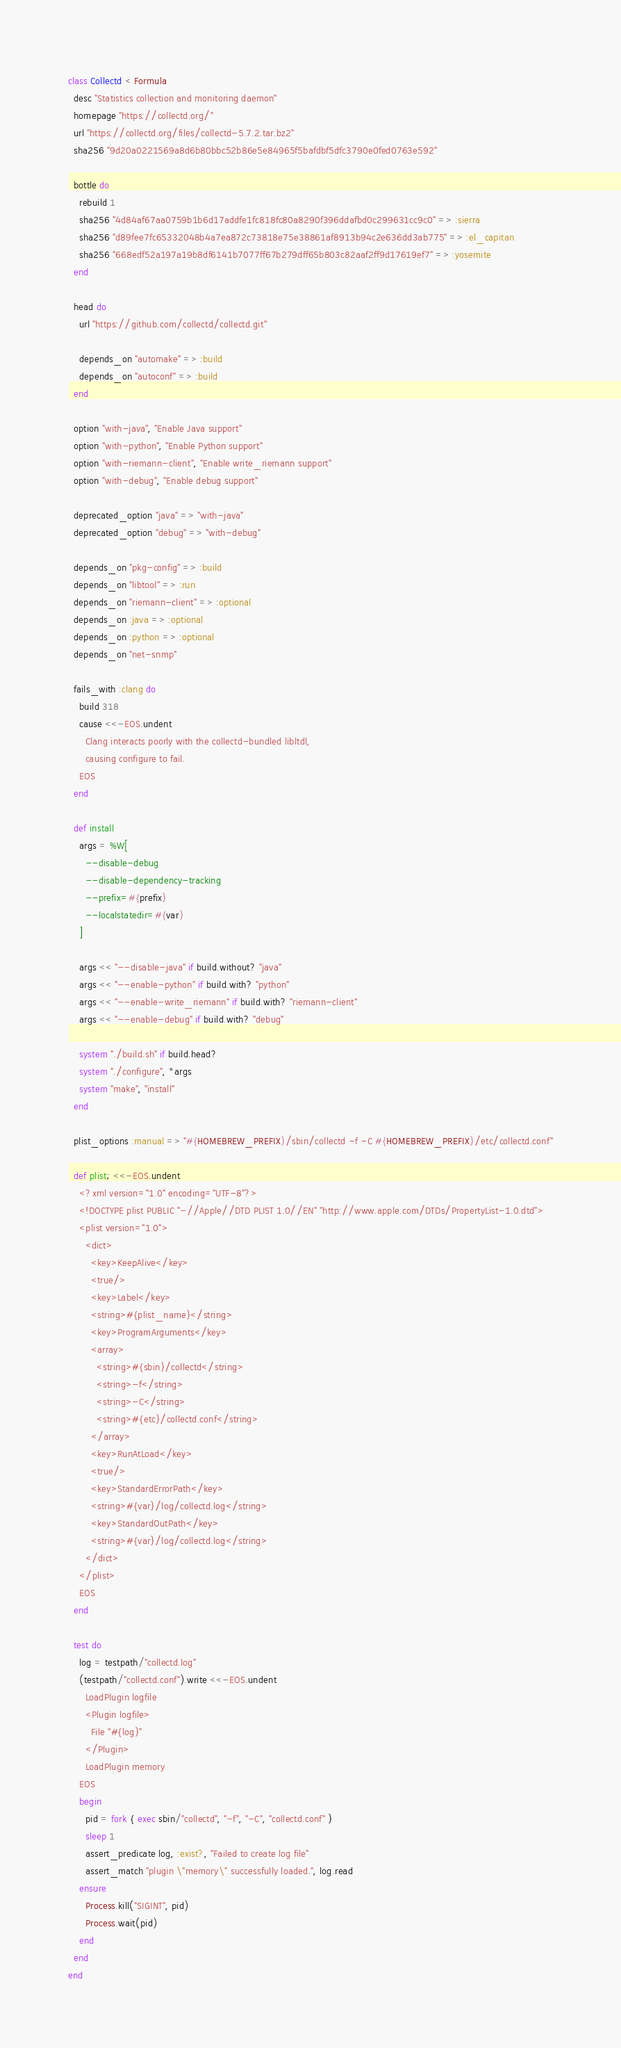<code> <loc_0><loc_0><loc_500><loc_500><_Ruby_>class Collectd < Formula
  desc "Statistics collection and monitoring daemon"
  homepage "https://collectd.org/"
  url "https://collectd.org/files/collectd-5.7.2.tar.bz2"
  sha256 "9d20a0221569a8d6b80bbc52b86e5e84965f5bafdbf5dfc3790e0fed0763e592"

  bottle do
    rebuild 1
    sha256 "4d84af67aa0759b1b6d17addfe1fc818fc80a8290f396ddafbd0c299631cc9c0" => :sierra
    sha256 "d89fee7fc65332048b4a7ea872c73818e75e38861af8913b94c2e636dd3ab775" => :el_capitan
    sha256 "668edf52a197a19b8df6141b7077ff67b279dff65b803c82aaf2ff9d17619ef7" => :yosemite
  end

  head do
    url "https://github.com/collectd/collectd.git"

    depends_on "automake" => :build
    depends_on "autoconf" => :build
  end

  option "with-java", "Enable Java support"
  option "with-python", "Enable Python support"
  option "with-riemann-client", "Enable write_riemann support"
  option "with-debug", "Enable debug support"

  deprecated_option "java" => "with-java"
  deprecated_option "debug" => "with-debug"

  depends_on "pkg-config" => :build
  depends_on "libtool" => :run
  depends_on "riemann-client" => :optional
  depends_on :java => :optional
  depends_on :python => :optional
  depends_on "net-snmp"

  fails_with :clang do
    build 318
    cause <<-EOS.undent
      Clang interacts poorly with the collectd-bundled libltdl,
      causing configure to fail.
    EOS
  end

  def install
    args = %W[
      --disable-debug
      --disable-dependency-tracking
      --prefix=#{prefix}
      --localstatedir=#{var}
    ]

    args << "--disable-java" if build.without? "java"
    args << "--enable-python" if build.with? "python"
    args << "--enable-write_riemann" if build.with? "riemann-client"
    args << "--enable-debug" if build.with? "debug"

    system "./build.sh" if build.head?
    system "./configure", *args
    system "make", "install"
  end

  plist_options :manual => "#{HOMEBREW_PREFIX}/sbin/collectd -f -C #{HOMEBREW_PREFIX}/etc/collectd.conf"

  def plist; <<-EOS.undent
    <?xml version="1.0" encoding="UTF-8"?>
    <!DOCTYPE plist PUBLIC "-//Apple//DTD PLIST 1.0//EN" "http://www.apple.com/DTDs/PropertyList-1.0.dtd">
    <plist version="1.0">
      <dict>
        <key>KeepAlive</key>
        <true/>
        <key>Label</key>
        <string>#{plist_name}</string>
        <key>ProgramArguments</key>
        <array>
          <string>#{sbin}/collectd</string>
          <string>-f</string>
          <string>-C</string>
          <string>#{etc}/collectd.conf</string>
        </array>
        <key>RunAtLoad</key>
        <true/>
        <key>StandardErrorPath</key>
        <string>#{var}/log/collectd.log</string>
        <key>StandardOutPath</key>
        <string>#{var}/log/collectd.log</string>
      </dict>
    </plist>
    EOS
  end

  test do
    log = testpath/"collectd.log"
    (testpath/"collectd.conf").write <<-EOS.undent
      LoadPlugin logfile
      <Plugin logfile>
        File "#{log}"
      </Plugin>
      LoadPlugin memory
    EOS
    begin
      pid = fork { exec sbin/"collectd", "-f", "-C", "collectd.conf" }
      sleep 1
      assert_predicate log, :exist?, "Failed to create log file"
      assert_match "plugin \"memory\" successfully loaded.", log.read
    ensure
      Process.kill("SIGINT", pid)
      Process.wait(pid)
    end
  end
end
</code> 